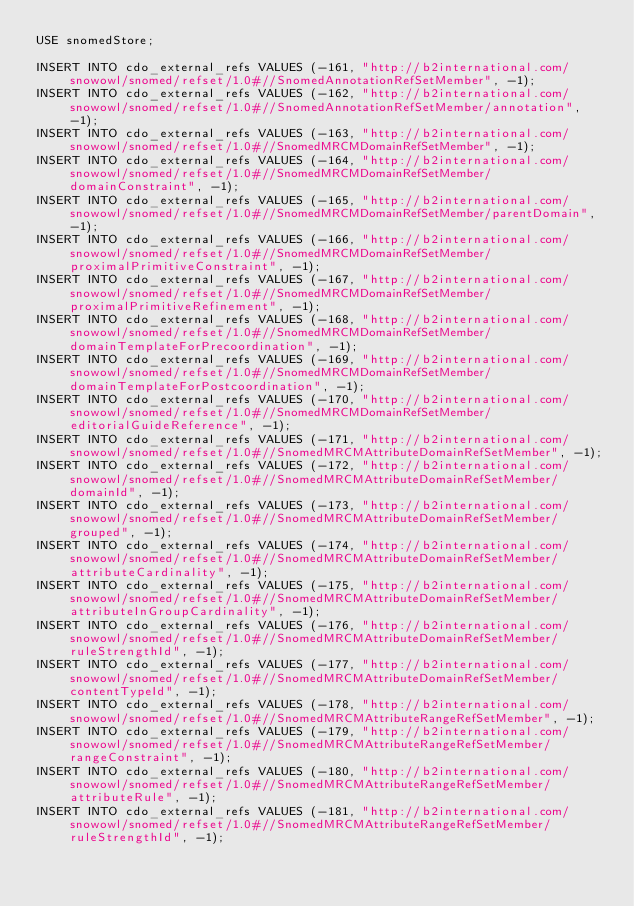<code> <loc_0><loc_0><loc_500><loc_500><_SQL_>USE snomedStore;

INSERT INTO cdo_external_refs VALUES (-161, "http://b2international.com/snowowl/snomed/refset/1.0#//SnomedAnnotationRefSetMember", -1);
INSERT INTO cdo_external_refs VALUES (-162, "http://b2international.com/snowowl/snomed/refset/1.0#//SnomedAnnotationRefSetMember/annotation", -1);
INSERT INTO cdo_external_refs VALUES (-163, "http://b2international.com/snowowl/snomed/refset/1.0#//SnomedMRCMDomainRefSetMember", -1);
INSERT INTO cdo_external_refs VALUES (-164, "http://b2international.com/snowowl/snomed/refset/1.0#//SnomedMRCMDomainRefSetMember/domainConstraint", -1);
INSERT INTO cdo_external_refs VALUES (-165, "http://b2international.com/snowowl/snomed/refset/1.0#//SnomedMRCMDomainRefSetMember/parentDomain", -1);
INSERT INTO cdo_external_refs VALUES (-166, "http://b2international.com/snowowl/snomed/refset/1.0#//SnomedMRCMDomainRefSetMember/proximalPrimitiveConstraint", -1);
INSERT INTO cdo_external_refs VALUES (-167, "http://b2international.com/snowowl/snomed/refset/1.0#//SnomedMRCMDomainRefSetMember/proximalPrimitiveRefinement", -1);
INSERT INTO cdo_external_refs VALUES (-168, "http://b2international.com/snowowl/snomed/refset/1.0#//SnomedMRCMDomainRefSetMember/domainTemplateForPrecoordination", -1);
INSERT INTO cdo_external_refs VALUES (-169, "http://b2international.com/snowowl/snomed/refset/1.0#//SnomedMRCMDomainRefSetMember/domainTemplateForPostcoordination", -1);
INSERT INTO cdo_external_refs VALUES (-170, "http://b2international.com/snowowl/snomed/refset/1.0#//SnomedMRCMDomainRefSetMember/editorialGuideReference", -1);
INSERT INTO cdo_external_refs VALUES (-171, "http://b2international.com/snowowl/snomed/refset/1.0#//SnomedMRCMAttributeDomainRefSetMember", -1);
INSERT INTO cdo_external_refs VALUES (-172, "http://b2international.com/snowowl/snomed/refset/1.0#//SnomedMRCMAttributeDomainRefSetMember/domainId", -1);
INSERT INTO cdo_external_refs VALUES (-173, "http://b2international.com/snowowl/snomed/refset/1.0#//SnomedMRCMAttributeDomainRefSetMember/grouped", -1);
INSERT INTO cdo_external_refs VALUES (-174, "http://b2international.com/snowowl/snomed/refset/1.0#//SnomedMRCMAttributeDomainRefSetMember/attributeCardinality", -1);
INSERT INTO cdo_external_refs VALUES (-175, "http://b2international.com/snowowl/snomed/refset/1.0#//SnomedMRCMAttributeDomainRefSetMember/attributeInGroupCardinality", -1);
INSERT INTO cdo_external_refs VALUES (-176, "http://b2international.com/snowowl/snomed/refset/1.0#//SnomedMRCMAttributeDomainRefSetMember/ruleStrengthId", -1);
INSERT INTO cdo_external_refs VALUES (-177, "http://b2international.com/snowowl/snomed/refset/1.0#//SnomedMRCMAttributeDomainRefSetMember/contentTypeId", -1);
INSERT INTO cdo_external_refs VALUES (-178, "http://b2international.com/snowowl/snomed/refset/1.0#//SnomedMRCMAttributeRangeRefSetMember", -1);
INSERT INTO cdo_external_refs VALUES (-179, "http://b2international.com/snowowl/snomed/refset/1.0#//SnomedMRCMAttributeRangeRefSetMember/rangeConstraint", -1);
INSERT INTO cdo_external_refs VALUES (-180, "http://b2international.com/snowowl/snomed/refset/1.0#//SnomedMRCMAttributeRangeRefSetMember/attributeRule", -1);
INSERT INTO cdo_external_refs VALUES (-181, "http://b2international.com/snowowl/snomed/refset/1.0#//SnomedMRCMAttributeRangeRefSetMember/ruleStrengthId", -1);</code> 